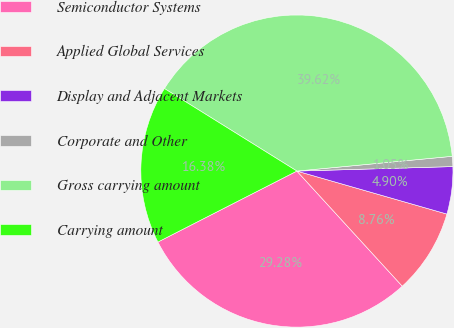<chart> <loc_0><loc_0><loc_500><loc_500><pie_chart><fcel>Semiconductor Systems<fcel>Applied Global Services<fcel>Display and Adjacent Markets<fcel>Corporate and Other<fcel>Gross carrying amount<fcel>Carrying amount<nl><fcel>29.28%<fcel>8.76%<fcel>4.9%<fcel>1.05%<fcel>39.62%<fcel>16.38%<nl></chart> 